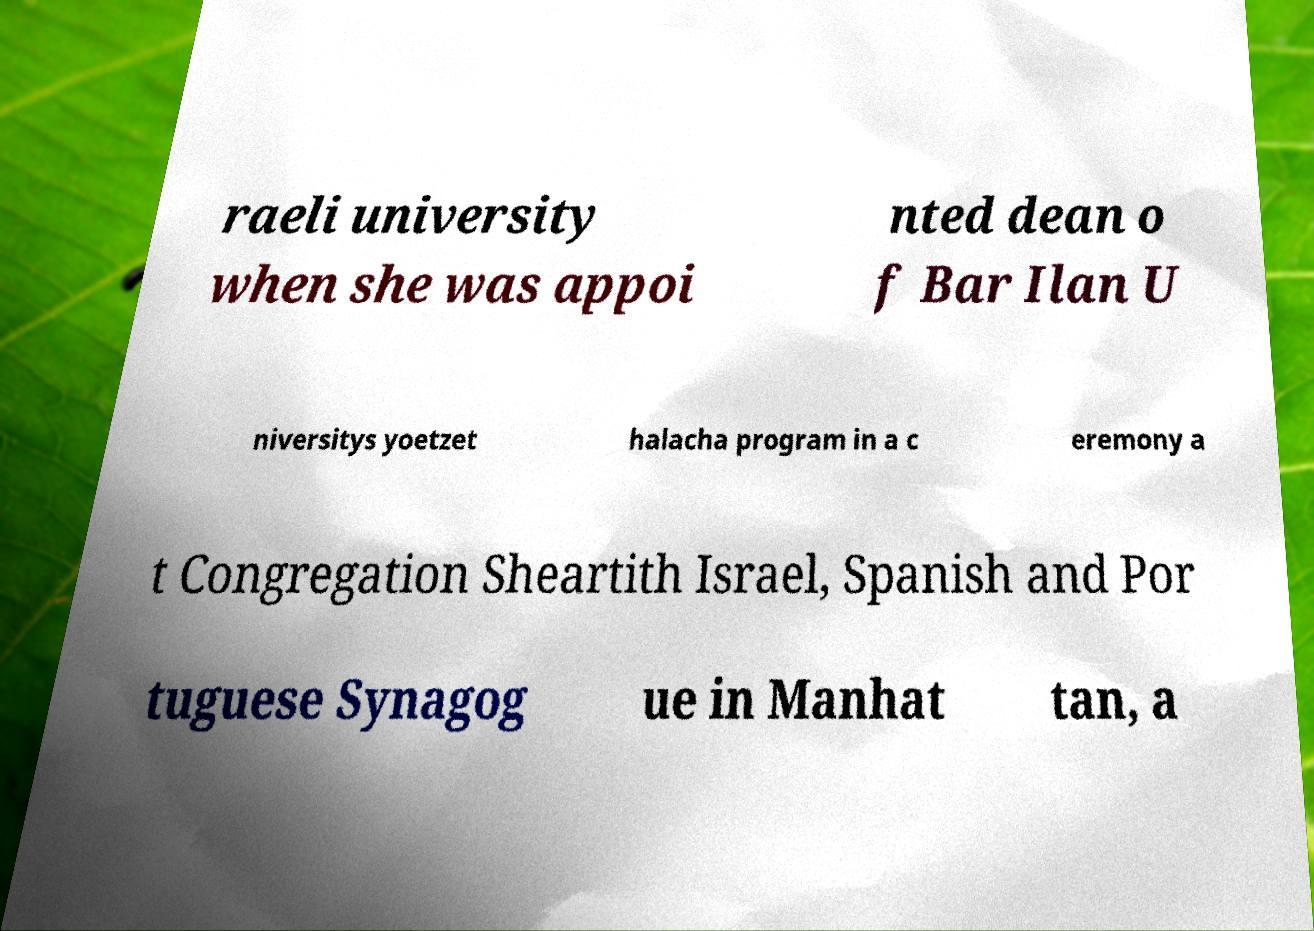For documentation purposes, I need the text within this image transcribed. Could you provide that? raeli university when she was appoi nted dean o f Bar Ilan U niversitys yoetzet halacha program in a c eremony a t Congregation Sheartith Israel, Spanish and Por tuguese Synagog ue in Manhat tan, a 